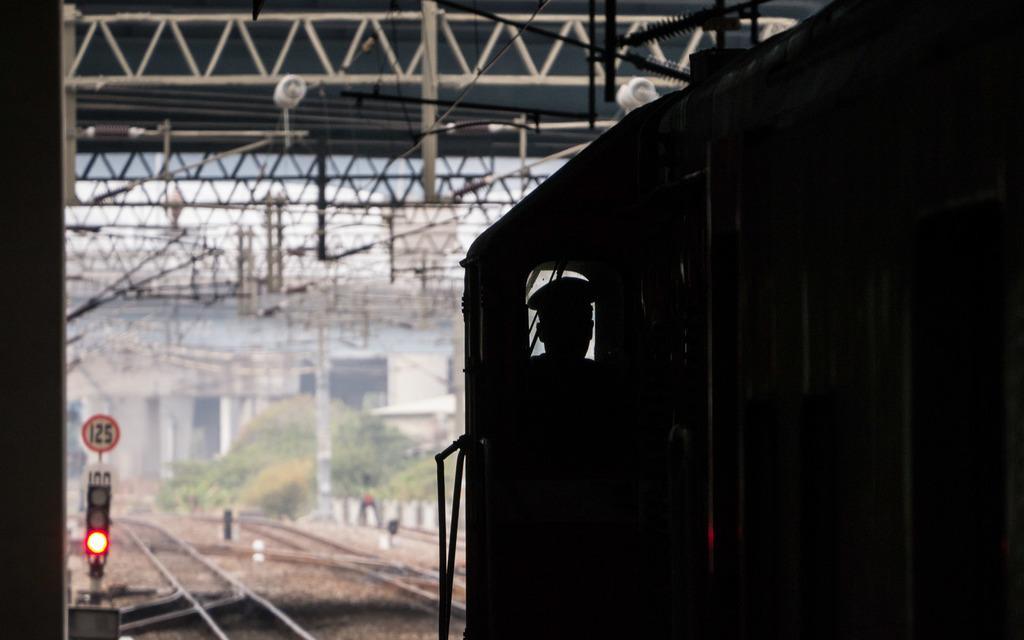In one or two sentences, can you explain what this image depicts? This image consists of a man driving train. At the bottom, there are tracks. To the left, there is a signal pole. At the top, there are stands along with wires. 